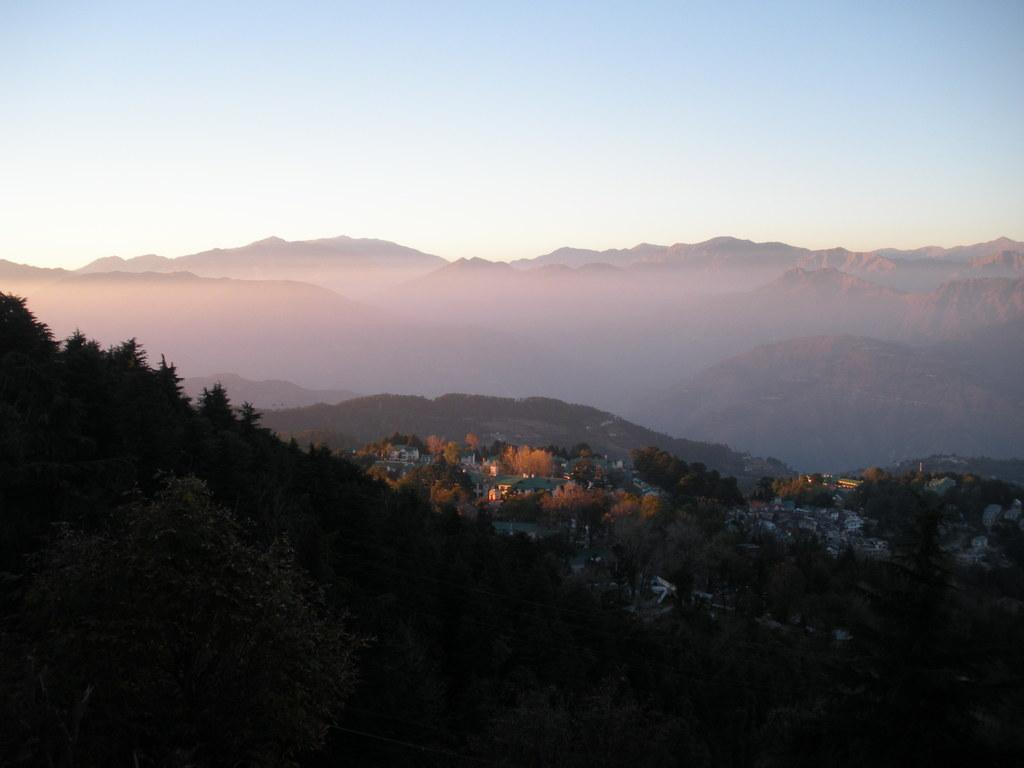What type of natural formation can be seen in the image? There are mountains in the image. What type of vegetation is visible at the bottom of the image? Trees are visible at the bottom of the image. What type of structures are present in the image? There is a building and a house in the image. What can be used for illumination in the image? Lights are present in the image. What is visible at the top of the image? The sky is visible at the top of the image. Can you tell me how many squirrels are climbing the trees in the image? There are no squirrels present in the image; only trees, mountains, a building, a house, lights, and the sky are visible. What type of door is featured on the house in the image? There is no door visible on the house in the image; only the building, house, and other elements are present. 